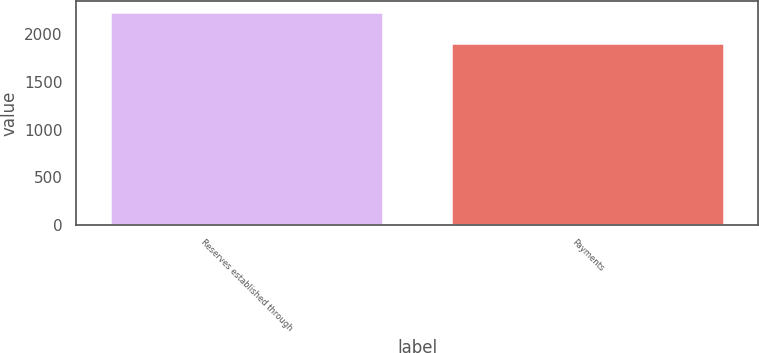Convert chart to OTSL. <chart><loc_0><loc_0><loc_500><loc_500><bar_chart><fcel>Reserves established through<fcel>Payments<nl><fcel>2240<fcel>1909<nl></chart> 